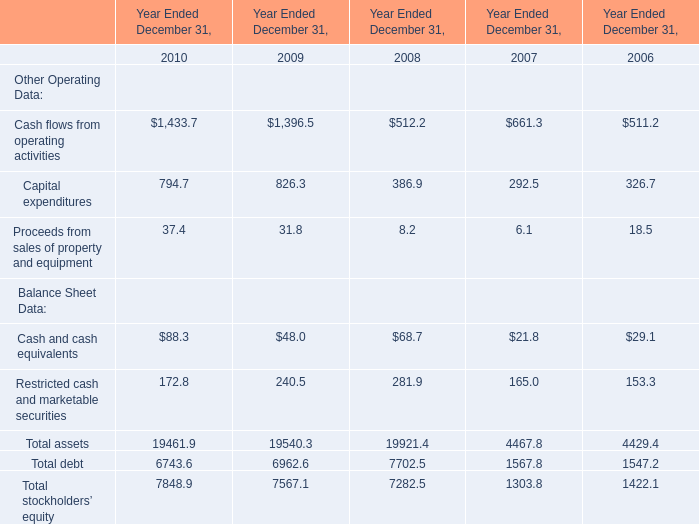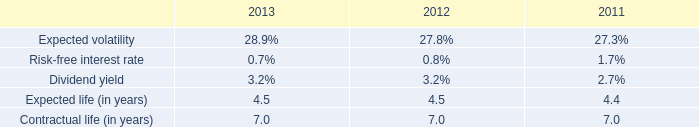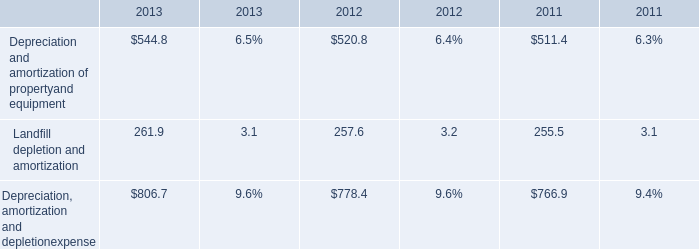How many element exceed the average of Capital expenditures and Proceeds from sales of property and equipment in 2010 ? 
Answer: 5. 